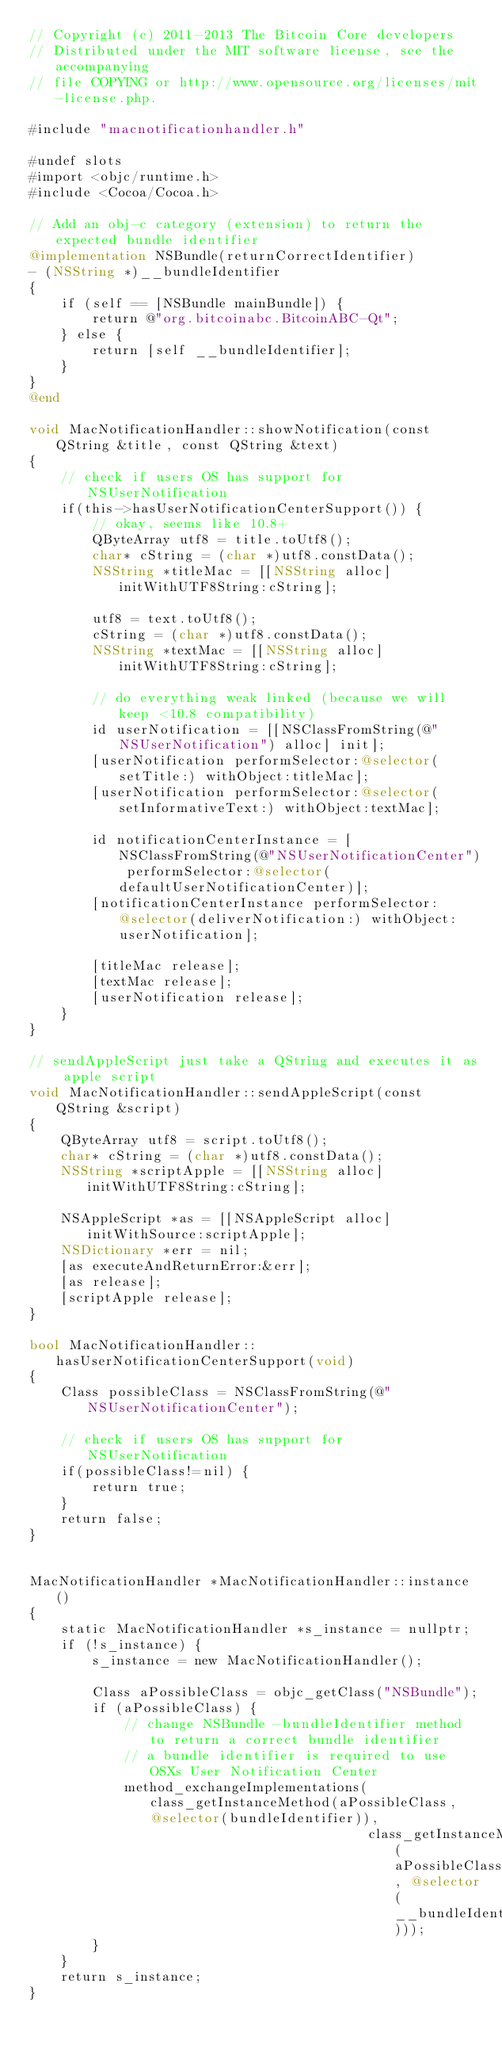Convert code to text. <code><loc_0><loc_0><loc_500><loc_500><_ObjectiveC_>// Copyright (c) 2011-2013 The Bitcoin Core developers
// Distributed under the MIT software license, see the accompanying
// file COPYING or http://www.opensource.org/licenses/mit-license.php.

#include "macnotificationhandler.h"

#undef slots
#import <objc/runtime.h>
#include <Cocoa/Cocoa.h>

// Add an obj-c category (extension) to return the expected bundle identifier
@implementation NSBundle(returnCorrectIdentifier)
- (NSString *)__bundleIdentifier
{
    if (self == [NSBundle mainBundle]) {
        return @"org.bitcoinabc.BitcoinABC-Qt";
    } else {
        return [self __bundleIdentifier];
    }
}
@end

void MacNotificationHandler::showNotification(const QString &title, const QString &text)
{
    // check if users OS has support for NSUserNotification
    if(this->hasUserNotificationCenterSupport()) {
        // okay, seems like 10.8+
        QByteArray utf8 = title.toUtf8();
        char* cString = (char *)utf8.constData();
        NSString *titleMac = [[NSString alloc] initWithUTF8String:cString];

        utf8 = text.toUtf8();
        cString = (char *)utf8.constData();
        NSString *textMac = [[NSString alloc] initWithUTF8String:cString];

        // do everything weak linked (because we will keep <10.8 compatibility)
        id userNotification = [[NSClassFromString(@"NSUserNotification") alloc] init];
        [userNotification performSelector:@selector(setTitle:) withObject:titleMac];
        [userNotification performSelector:@selector(setInformativeText:) withObject:textMac];

        id notificationCenterInstance = [NSClassFromString(@"NSUserNotificationCenter") performSelector:@selector(defaultUserNotificationCenter)];
        [notificationCenterInstance performSelector:@selector(deliverNotification:) withObject:userNotification];

        [titleMac release];
        [textMac release];
        [userNotification release];
    }
}

// sendAppleScript just take a QString and executes it as apple script
void MacNotificationHandler::sendAppleScript(const QString &script)
{
    QByteArray utf8 = script.toUtf8();
    char* cString = (char *)utf8.constData();
    NSString *scriptApple = [[NSString alloc] initWithUTF8String:cString];

    NSAppleScript *as = [[NSAppleScript alloc] initWithSource:scriptApple];
    NSDictionary *err = nil;
    [as executeAndReturnError:&err];
    [as release];
    [scriptApple release];
}

bool MacNotificationHandler::hasUserNotificationCenterSupport(void)
{
    Class possibleClass = NSClassFromString(@"NSUserNotificationCenter");

    // check if users OS has support for NSUserNotification
    if(possibleClass!=nil) {
        return true;
    }
    return false;
}


MacNotificationHandler *MacNotificationHandler::instance()
{
    static MacNotificationHandler *s_instance = nullptr;
    if (!s_instance) {
        s_instance = new MacNotificationHandler();
        
        Class aPossibleClass = objc_getClass("NSBundle");
        if (aPossibleClass) {
            // change NSBundle -bundleIdentifier method to return a correct bundle identifier
            // a bundle identifier is required to use OSXs User Notification Center
            method_exchangeImplementations(class_getInstanceMethod(aPossibleClass, @selector(bundleIdentifier)),
                                           class_getInstanceMethod(aPossibleClass, @selector(__bundleIdentifier)));
        }
    }
    return s_instance;
}
</code> 